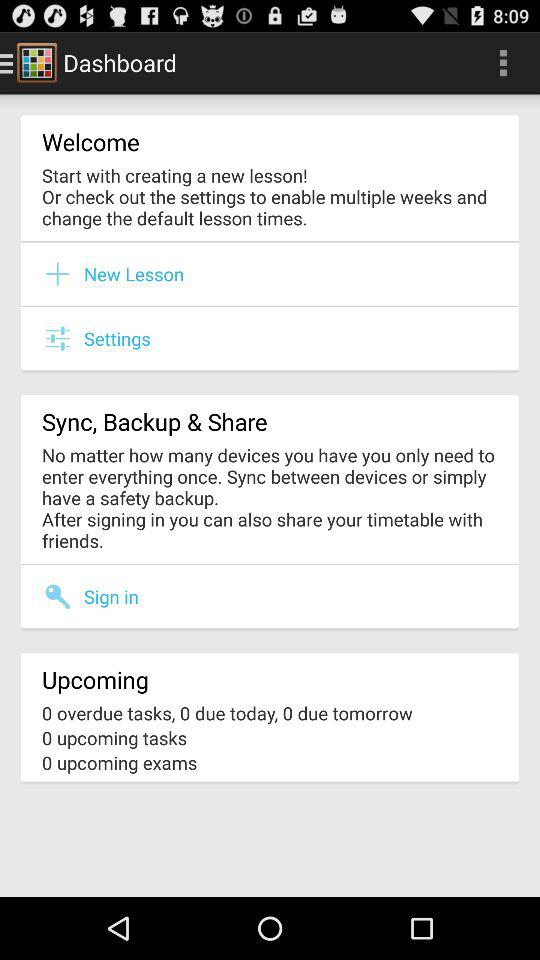What is the upcoming task count? The upcoming task count is 0. 